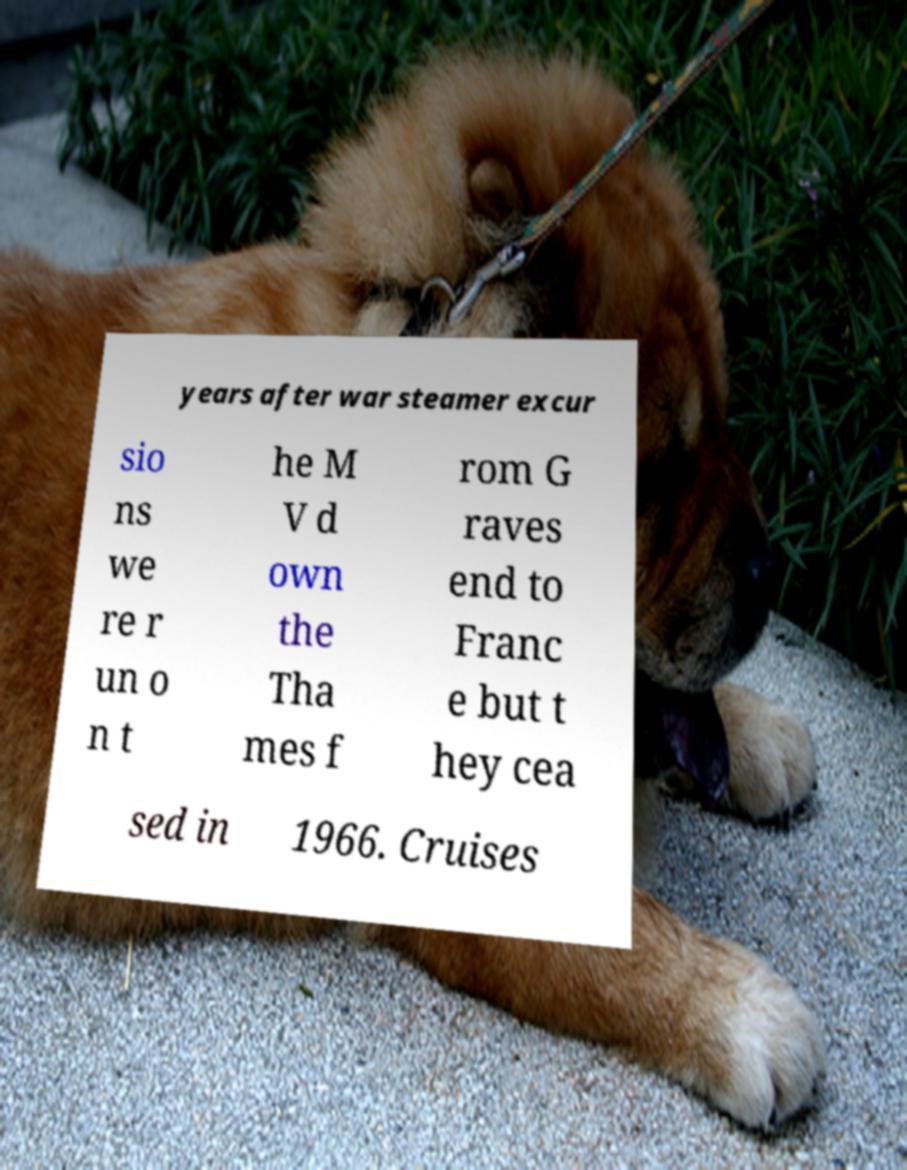There's text embedded in this image that I need extracted. Can you transcribe it verbatim? years after war steamer excur sio ns we re r un o n t he M V d own the Tha mes f rom G raves end to Franc e but t hey cea sed in 1966. Cruises 